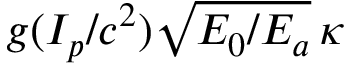Convert formula to latex. <formula><loc_0><loc_0><loc_500><loc_500>g ( I _ { p } / c ^ { 2 } ) \sqrt { E _ { 0 } / E _ { a } } \, \kappa</formula> 